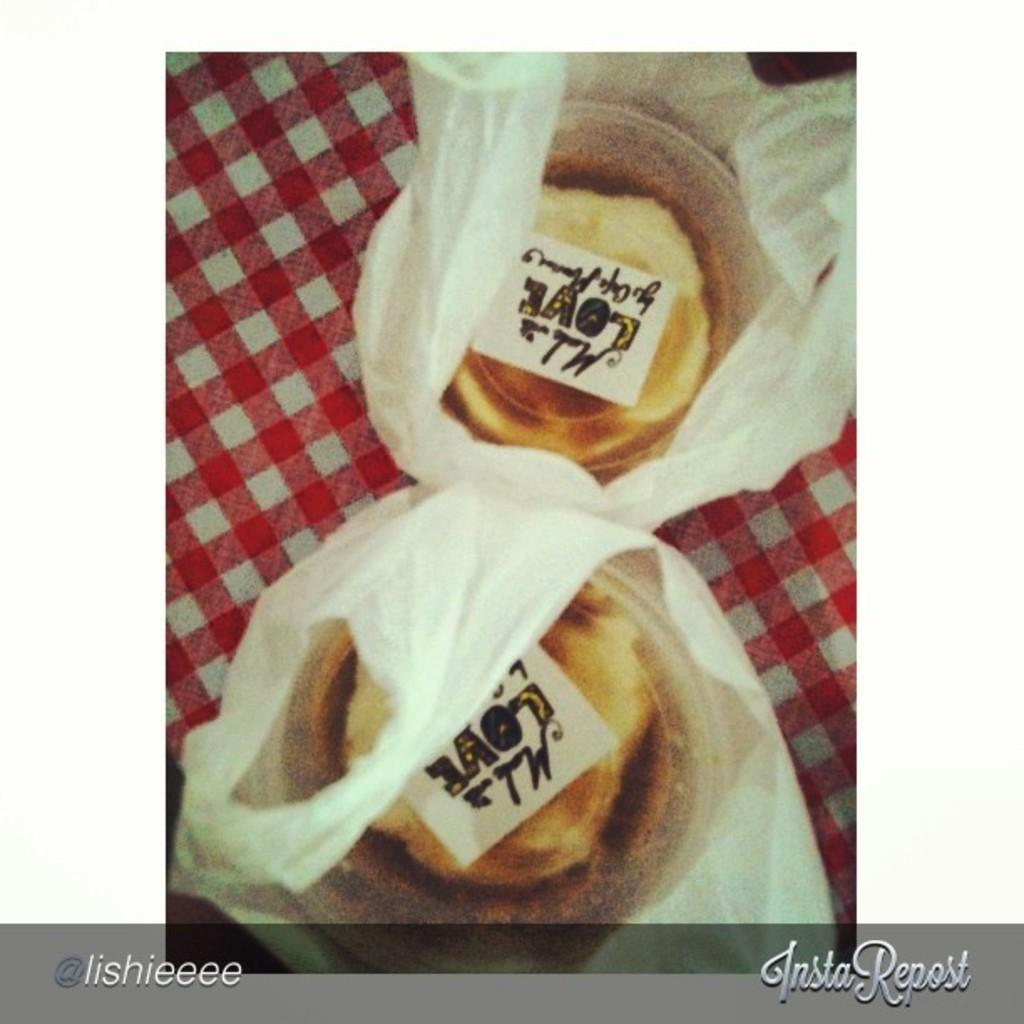What is inside the boxes that are visible in the image? The boxes contain food. How are the boxes with food being transported or carried? The boxes are in a carry bag. What type of experience does the person have while eating the food in the image? There is no person present in the image, so it is not possible to determine their experience while eating the food. 